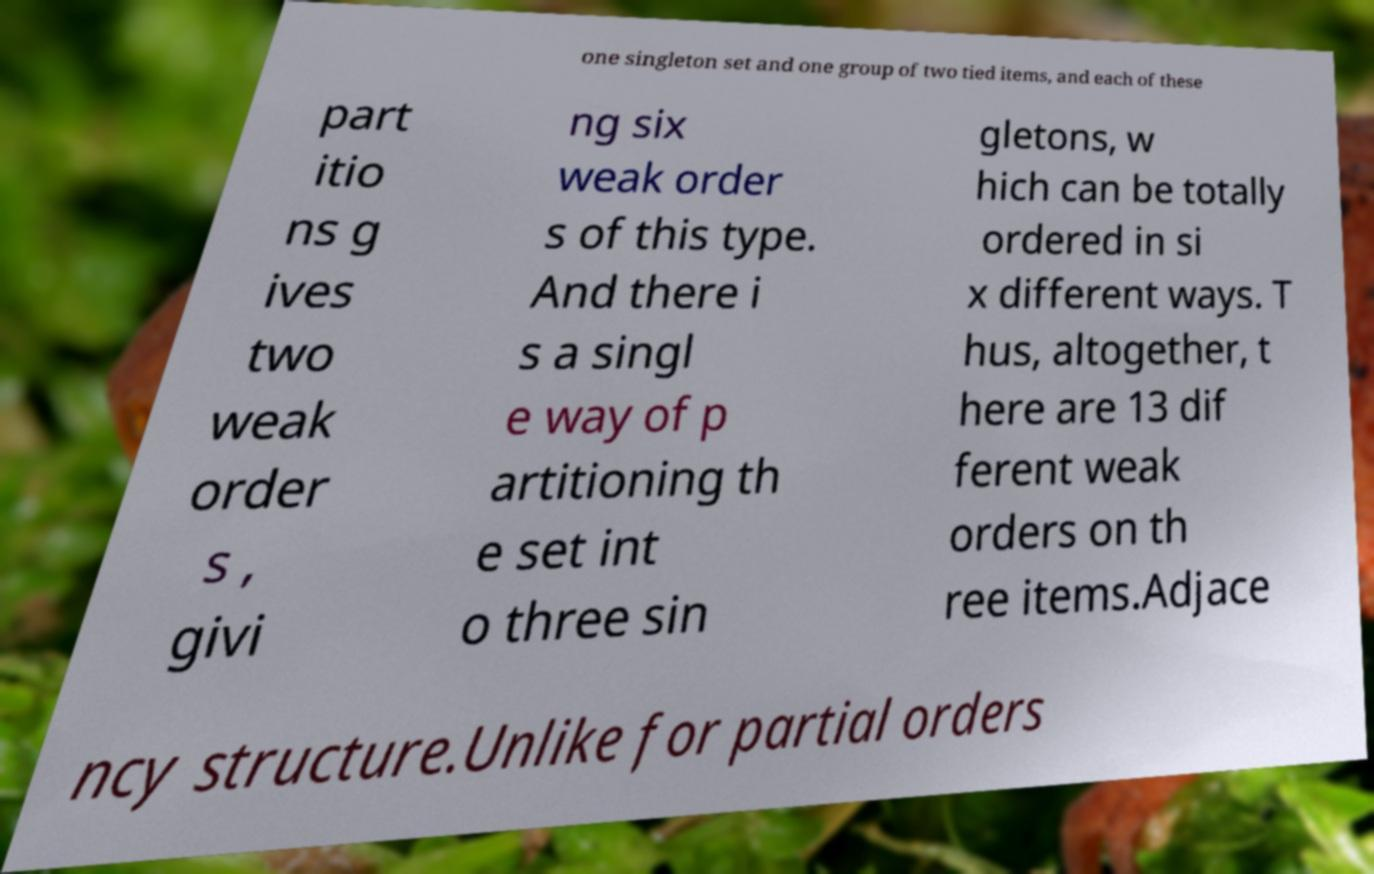Please identify and transcribe the text found in this image. one singleton set and one group of two tied items, and each of these part itio ns g ives two weak order s , givi ng six weak order s of this type. And there i s a singl e way of p artitioning th e set int o three sin gletons, w hich can be totally ordered in si x different ways. T hus, altogether, t here are 13 dif ferent weak orders on th ree items.Adjace ncy structure.Unlike for partial orders 